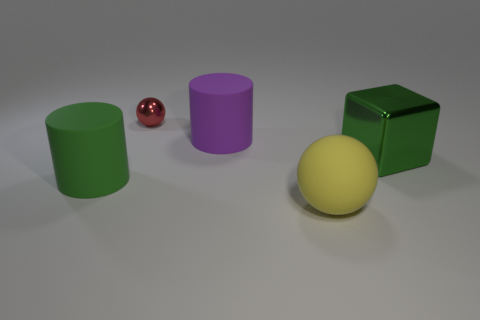Is there any other thing that is the same size as the red ball?
Keep it short and to the point. No. Is there anything else that is the same shape as the large green metallic object?
Provide a short and direct response. No. Are there fewer green objects than large yellow rubber spheres?
Your answer should be very brief. No. Is the large object that is behind the green metal thing made of the same material as the large yellow sphere?
Provide a short and direct response. Yes. What number of balls are large cyan metallic things or small metallic things?
Offer a terse response. 1. There is a thing that is both behind the big metal thing and in front of the shiny sphere; what shape is it?
Your answer should be compact. Cylinder. What color is the matte cylinder that is right of the sphere that is behind the large object that is on the left side of the purple rubber thing?
Offer a very short reply. Purple. Are there fewer purple rubber things that are on the left side of the tiny red ball than spheres?
Offer a very short reply. Yes. Does the green object left of the big metal thing have the same shape as the large matte object that is behind the green metallic cube?
Make the answer very short. Yes. What number of things are large matte objects that are left of the red metal thing or purple matte things?
Offer a very short reply. 2. 